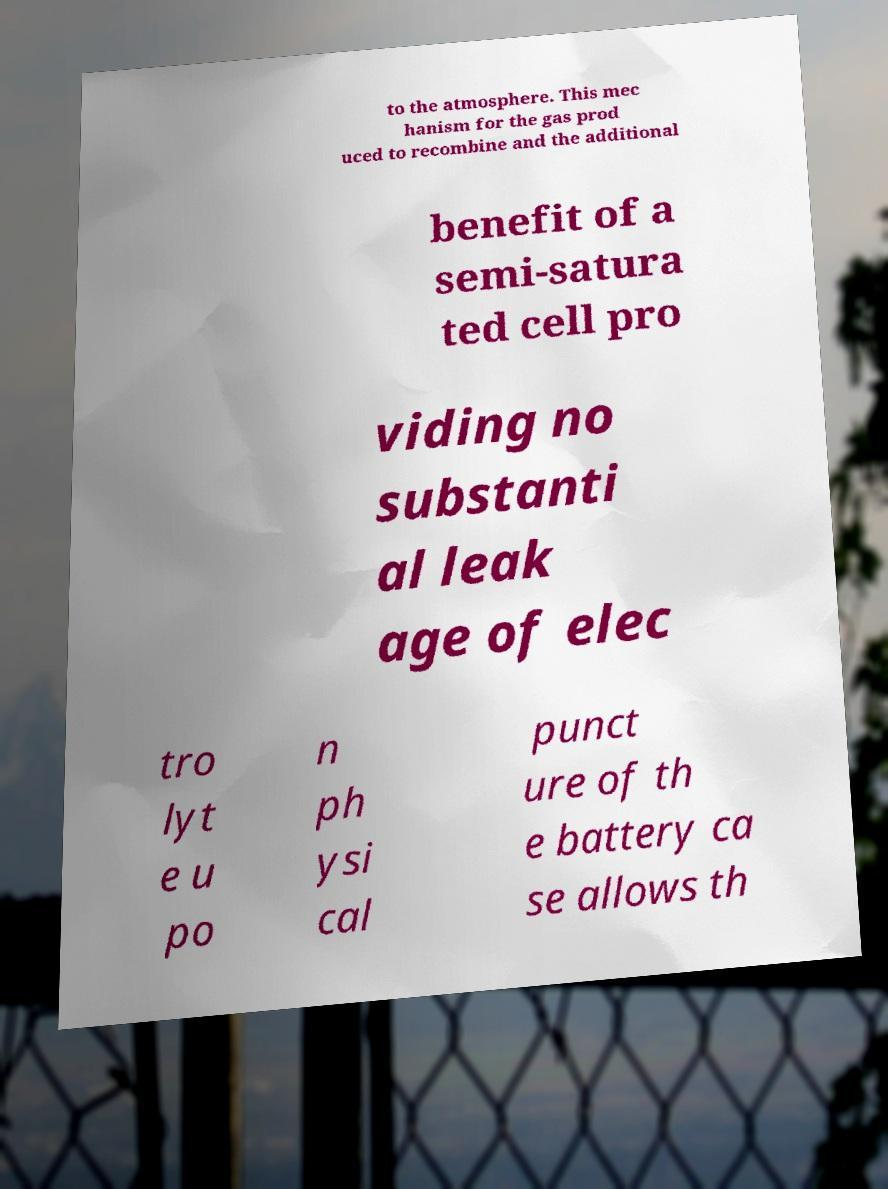Can you read and provide the text displayed in the image?This photo seems to have some interesting text. Can you extract and type it out for me? to the atmosphere. This mec hanism for the gas prod uced to recombine and the additional benefit of a semi-satura ted cell pro viding no substanti al leak age of elec tro lyt e u po n ph ysi cal punct ure of th e battery ca se allows th 